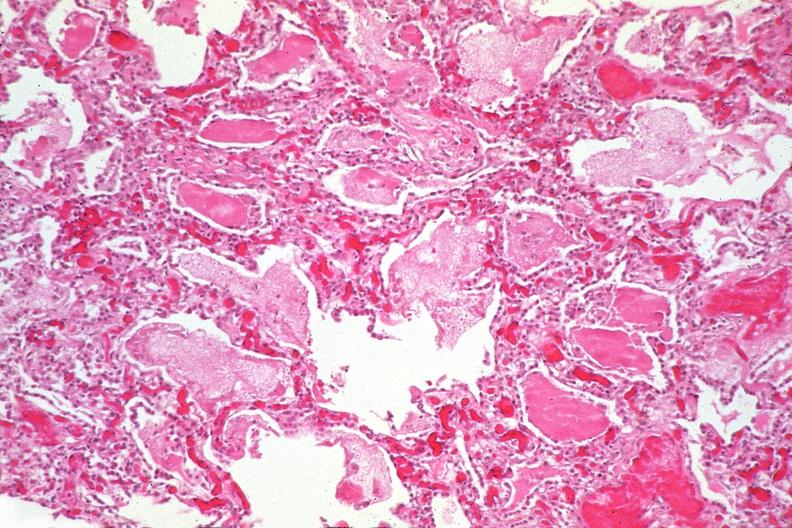what is present?
Answer the question using a single word or phrase. Respiratory 